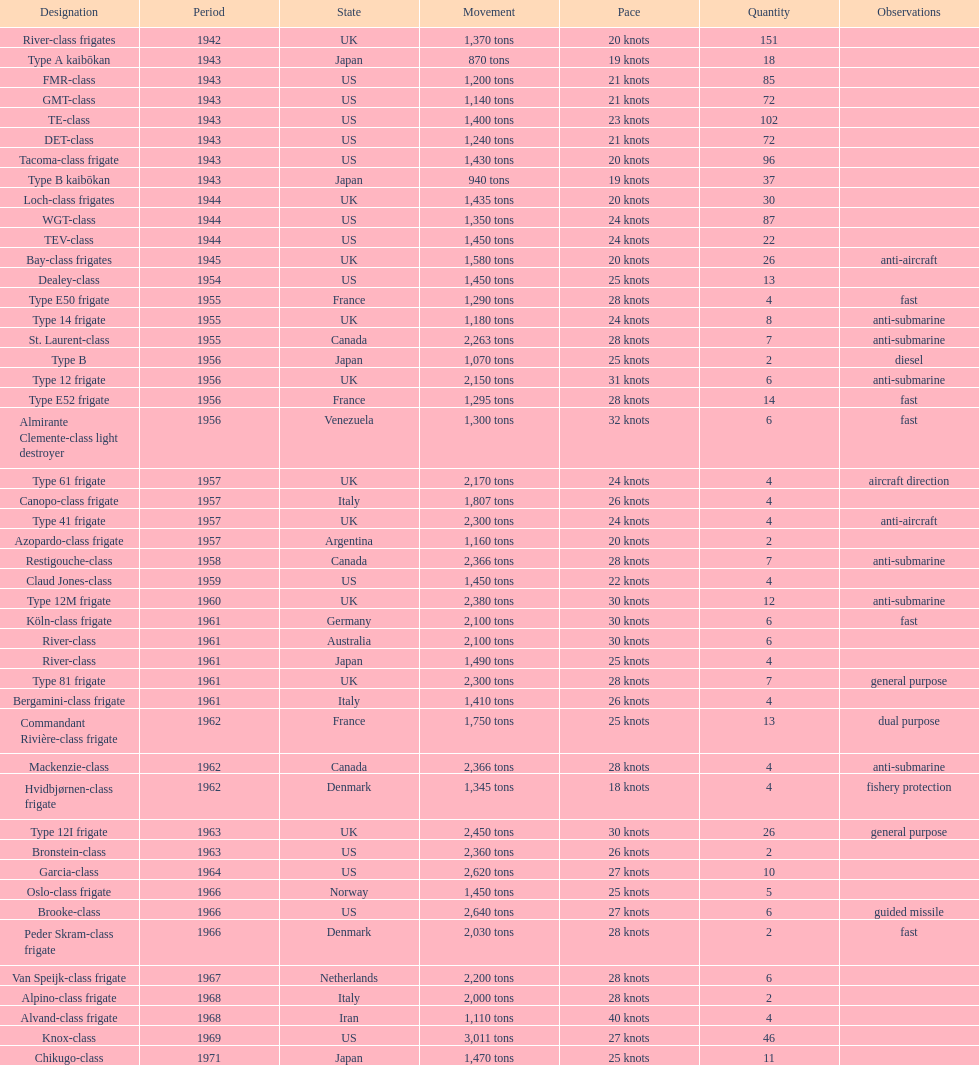What is the top speed? 40 knots. 